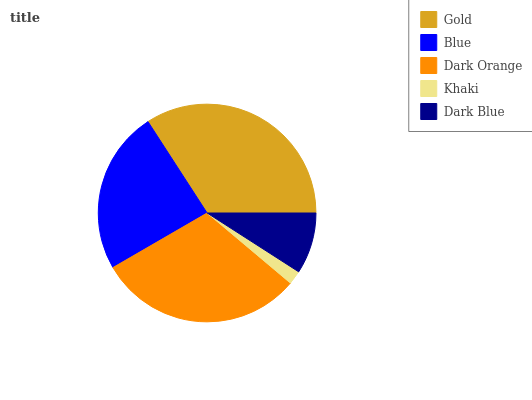Is Khaki the minimum?
Answer yes or no. Yes. Is Gold the maximum?
Answer yes or no. Yes. Is Blue the minimum?
Answer yes or no. No. Is Blue the maximum?
Answer yes or no. No. Is Gold greater than Blue?
Answer yes or no. Yes. Is Blue less than Gold?
Answer yes or no. Yes. Is Blue greater than Gold?
Answer yes or no. No. Is Gold less than Blue?
Answer yes or no. No. Is Blue the high median?
Answer yes or no. Yes. Is Blue the low median?
Answer yes or no. Yes. Is Dark Orange the high median?
Answer yes or no. No. Is Gold the low median?
Answer yes or no. No. 